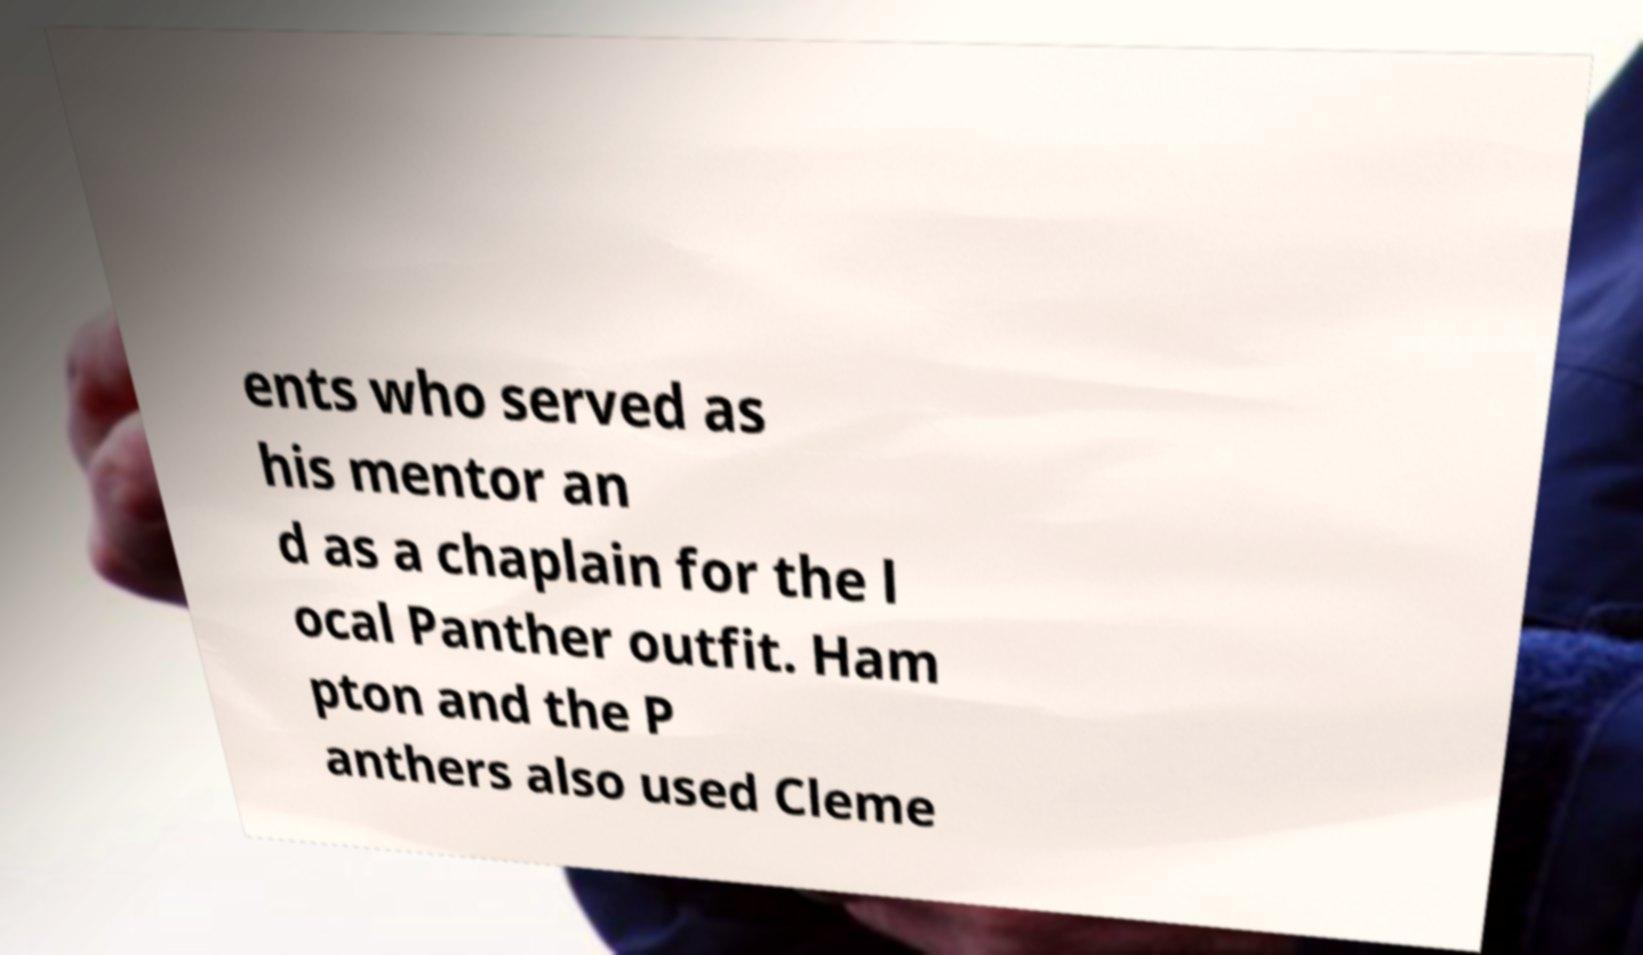Could you extract and type out the text from this image? ents who served as his mentor an d as a chaplain for the l ocal Panther outfit. Ham pton and the P anthers also used Cleme 